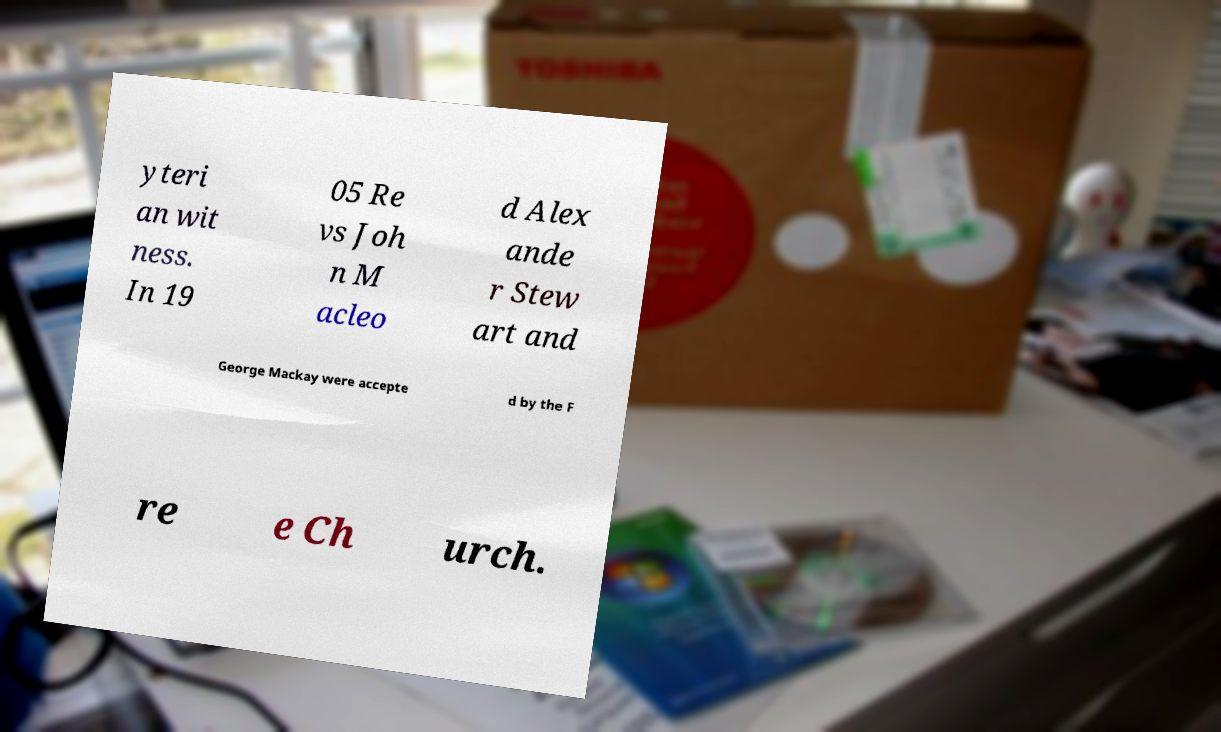Please identify and transcribe the text found in this image. yteri an wit ness. In 19 05 Re vs Joh n M acleo d Alex ande r Stew art and George Mackay were accepte d by the F re e Ch urch. 